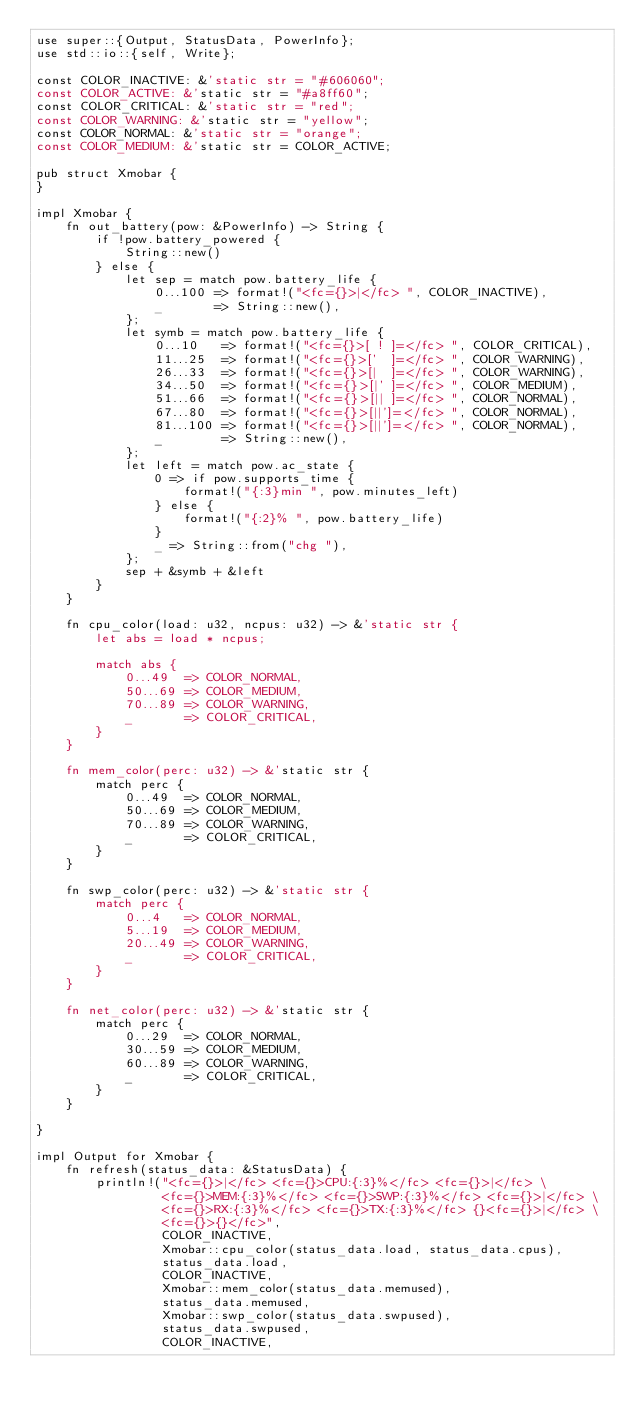Convert code to text. <code><loc_0><loc_0><loc_500><loc_500><_Rust_>use super::{Output, StatusData, PowerInfo};
use std::io::{self, Write};

const COLOR_INACTIVE: &'static str = "#606060";
const COLOR_ACTIVE: &'static str = "#a8ff60";
const COLOR_CRITICAL: &'static str = "red";
const COLOR_WARNING: &'static str = "yellow";
const COLOR_NORMAL: &'static str = "orange";
const COLOR_MEDIUM: &'static str = COLOR_ACTIVE;

pub struct Xmobar {
}

impl Xmobar {
    fn out_battery(pow: &PowerInfo) -> String {
        if !pow.battery_powered {
            String::new()
        } else {
            let sep = match pow.battery_life {
                0...100 => format!("<fc={}>|</fc> ", COLOR_INACTIVE),
                _       => String::new(),
            };
            let symb = match pow.battery_life {
                0...10   => format!("<fc={}>[ ! ]=</fc> ", COLOR_CRITICAL),
                11...25  => format!("<fc={}>['  ]=</fc> ", COLOR_WARNING),
                26...33  => format!("<fc={}>[|  ]=</fc> ", COLOR_WARNING),
                34...50  => format!("<fc={}>[|' ]=</fc> ", COLOR_MEDIUM),
                51...66  => format!("<fc={}>[|| ]=</fc> ", COLOR_NORMAL),
                67...80  => format!("<fc={}>[||']=</fc> ", COLOR_NORMAL),
                81...100 => format!("<fc={}>[||']=</fc> ", COLOR_NORMAL),
                _        => String::new(),
            };
            let left = match pow.ac_state {
                0 => if pow.supports_time {
                    format!("{:3}min ", pow.minutes_left)
                } else {
                    format!("{:2}% ", pow.battery_life)
                }
                _ => String::from("chg "),
            };
            sep + &symb + &left
        }
    }

    fn cpu_color(load: u32, ncpus: u32) -> &'static str {
        let abs = load * ncpus;

        match abs {
            0...49  => COLOR_NORMAL,
            50...69 => COLOR_MEDIUM,
            70...89 => COLOR_WARNING,
            _       => COLOR_CRITICAL,
        }
    }

    fn mem_color(perc: u32) -> &'static str {
        match perc {
            0...49  => COLOR_NORMAL,
            50...69 => COLOR_MEDIUM,
            70...89 => COLOR_WARNING,
            _       => COLOR_CRITICAL,
        }
    }

    fn swp_color(perc: u32) -> &'static str {
        match perc {
            0...4   => COLOR_NORMAL,
            5...19  => COLOR_MEDIUM,
            20...49 => COLOR_WARNING,
            _       => COLOR_CRITICAL,
        }
    }

    fn net_color(perc: u32) -> &'static str {
        match perc {
            0...29  => COLOR_NORMAL,
            30...59 => COLOR_MEDIUM,
            60...89 => COLOR_WARNING,
            _       => COLOR_CRITICAL,
        }
    }

}

impl Output for Xmobar {
    fn refresh(status_data: &StatusData) {
        println!("<fc={}>|</fc> <fc={}>CPU:{:3}%</fc> <fc={}>|</fc> \
                 <fc={}>MEM:{:3}%</fc> <fc={}>SWP:{:3}%</fc> <fc={}>|</fc> \
                 <fc={}>RX:{:3}%</fc> <fc={}>TX:{:3}%</fc> {}<fc={}>|</fc> \
                 <fc={}>{}</fc>",
                 COLOR_INACTIVE,
                 Xmobar::cpu_color(status_data.load, status_data.cpus),
                 status_data.load,
                 COLOR_INACTIVE,
                 Xmobar::mem_color(status_data.memused),
                 status_data.memused,
                 Xmobar::swp_color(status_data.swpused),
                 status_data.swpused,
                 COLOR_INACTIVE,</code> 